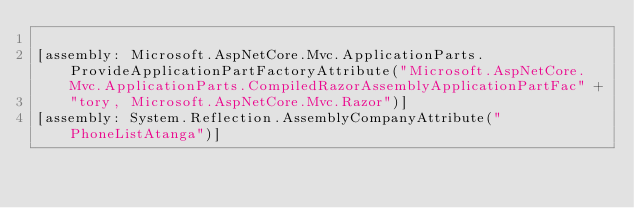Convert code to text. <code><loc_0><loc_0><loc_500><loc_500><_C#_>
[assembly: Microsoft.AspNetCore.Mvc.ApplicationParts.ProvideApplicationPartFactoryAttribute("Microsoft.AspNetCore.Mvc.ApplicationParts.CompiledRazorAssemblyApplicationPartFac" +
    "tory, Microsoft.AspNetCore.Mvc.Razor")]
[assembly: System.Reflection.AssemblyCompanyAttribute("PhoneListAtanga")]</code> 